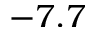<formula> <loc_0><loc_0><loc_500><loc_500>- 7 . 7</formula> 